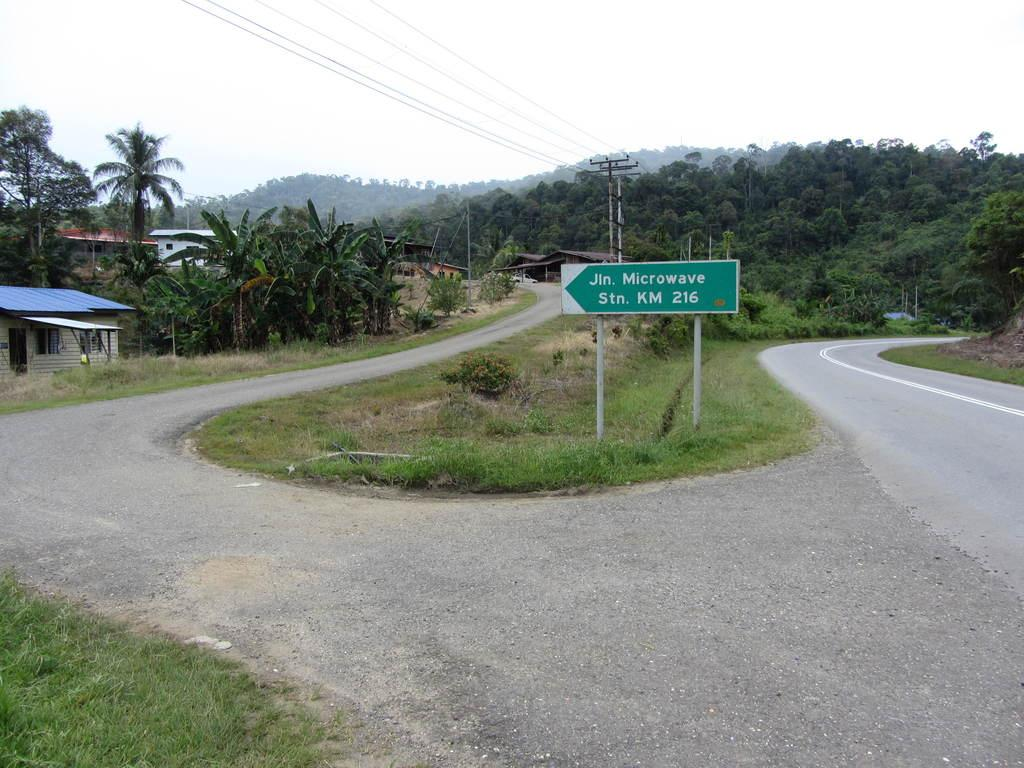What type of structures can be seen in the image? There are houses in the image. What natural elements are present in the image? There are trees and grass in the image. What man-made feature is visible in the image? There is a road in the image. What additional object can be found in the image? There is an informational board in the image. What utility infrastructure is present in the image? There are electrical poles with wires in the image. What part of the natural environment is visible in the image? The sky is visible in the image. What type of pancake is being served on the informational board in the image? There is no pancake present on the informational board in the image. How many limits can be seen on the electrical poles in the image? There are no limits visible on the electrical poles in the image. 